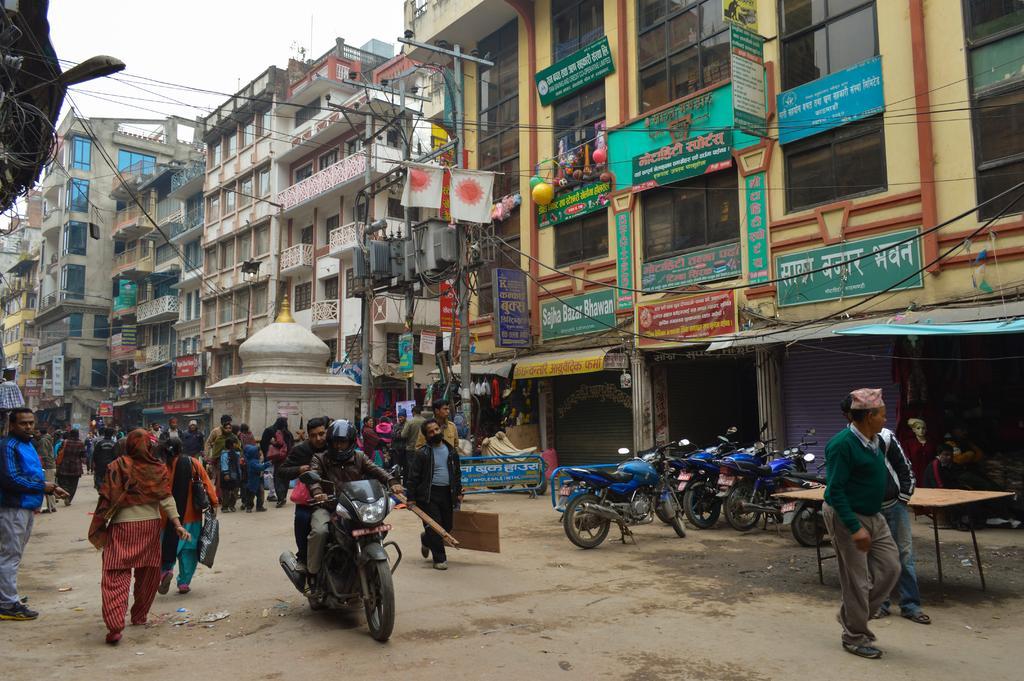Describe this image in one or two sentences. In this picture we can see buildings with windows and balcony and some flags are attached to the poles to the window and here is a road where two persons are on bike and other are walking and beside to this we have motorbikes parked, shutters, pillars, table and above the building we have sky. 